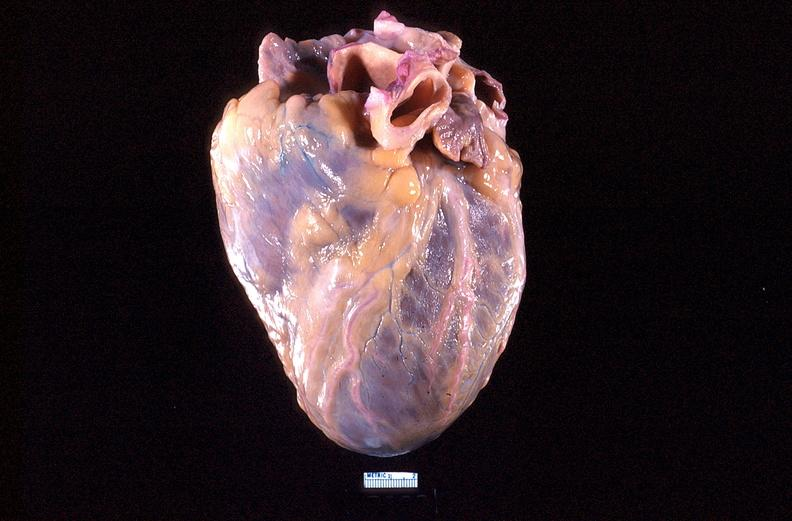where is this?
Answer the question using a single word or phrase. Heart 